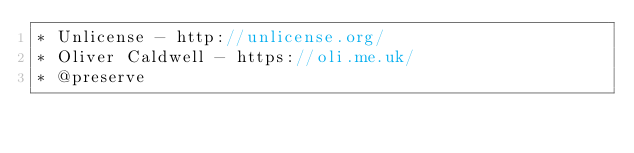Convert code to text. <code><loc_0><loc_0><loc_500><loc_500><_JavaScript_>* Unlicense - http://unlicense.org/
* Oliver Caldwell - https://oli.me.uk/
* @preserve</code> 